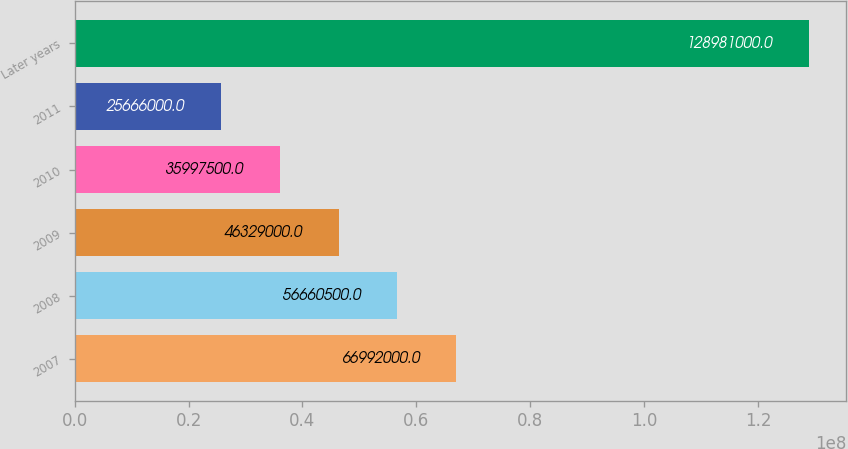Convert chart to OTSL. <chart><loc_0><loc_0><loc_500><loc_500><bar_chart><fcel>2007<fcel>2008<fcel>2009<fcel>2010<fcel>2011<fcel>Later years<nl><fcel>6.6992e+07<fcel>5.66605e+07<fcel>4.6329e+07<fcel>3.59975e+07<fcel>2.5666e+07<fcel>1.28981e+08<nl></chart> 